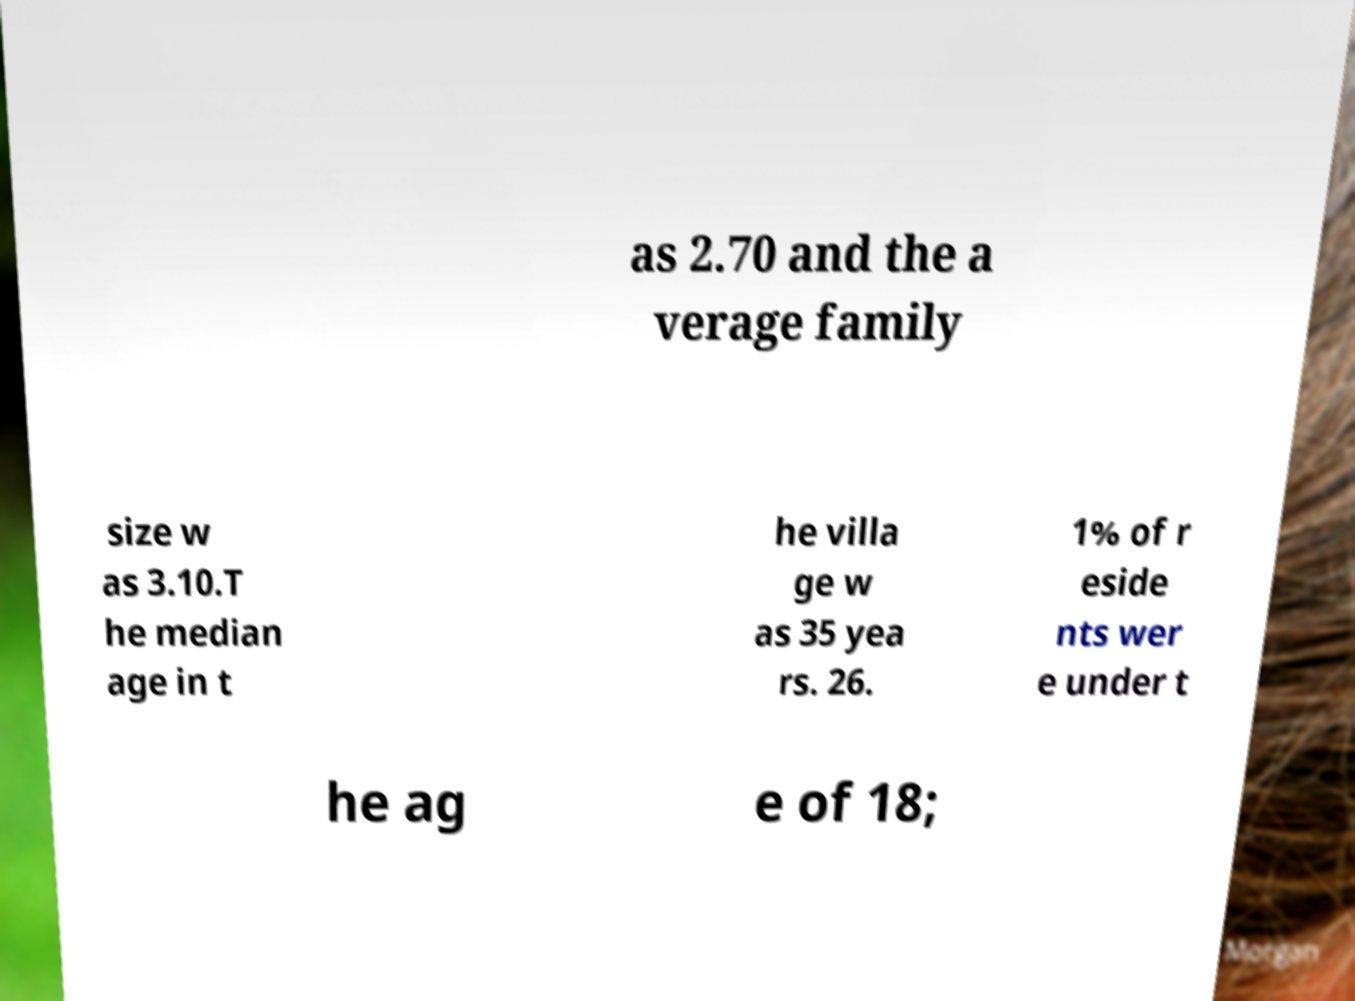Please read and relay the text visible in this image. What does it say? as 2.70 and the a verage family size w as 3.10.T he median age in t he villa ge w as 35 yea rs. 26. 1% of r eside nts wer e under t he ag e of 18; 